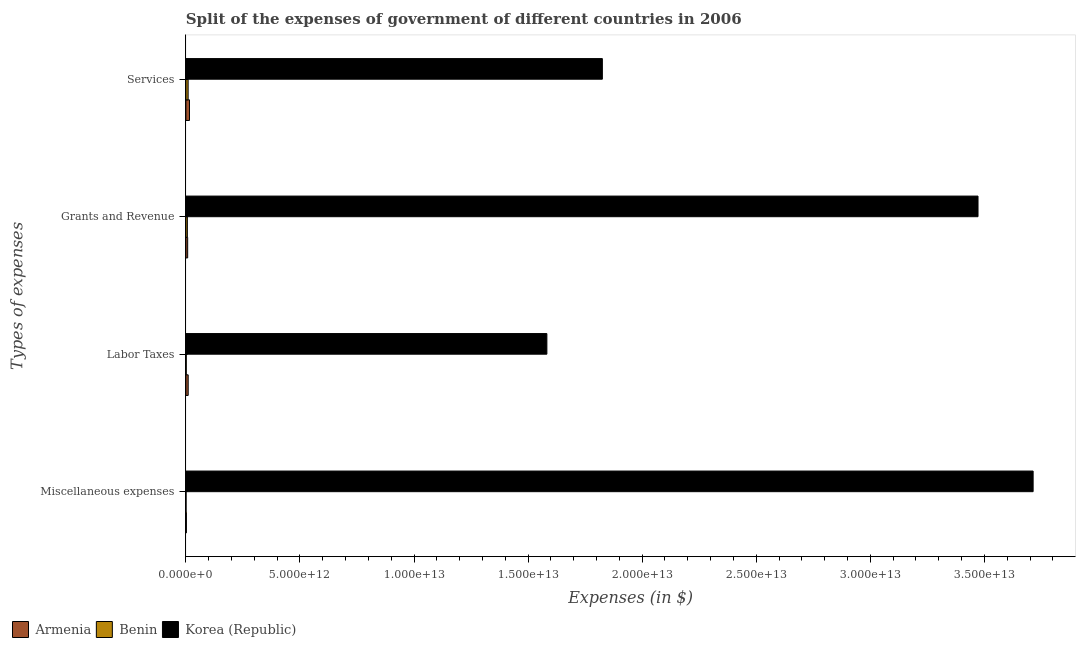How many bars are there on the 2nd tick from the bottom?
Give a very brief answer. 3. What is the label of the 2nd group of bars from the top?
Offer a terse response. Grants and Revenue. What is the amount spent on miscellaneous expenses in Armenia?
Give a very brief answer. 2.16e+1. Across all countries, what is the maximum amount spent on services?
Your answer should be very brief. 1.83e+13. Across all countries, what is the minimum amount spent on miscellaneous expenses?
Offer a terse response. 7.16e+09. In which country was the amount spent on labor taxes minimum?
Give a very brief answer. Benin. What is the total amount spent on services in the graph?
Keep it short and to the point. 1.85e+13. What is the difference between the amount spent on services in Benin and that in Armenia?
Keep it short and to the point. -5.98e+1. What is the difference between the amount spent on miscellaneous expenses in Armenia and the amount spent on labor taxes in Korea (Republic)?
Make the answer very short. -1.58e+13. What is the average amount spent on grants and revenue per country?
Ensure brevity in your answer.  1.16e+13. What is the difference between the amount spent on miscellaneous expenses and amount spent on grants and revenue in Korea (Republic)?
Make the answer very short. 2.42e+12. In how many countries, is the amount spent on grants and revenue greater than 18000000000000 $?
Give a very brief answer. 1. What is the ratio of the amount spent on grants and revenue in Armenia to that in Benin?
Provide a short and direct response. 1.21. Is the amount spent on grants and revenue in Armenia less than that in Korea (Republic)?
Provide a succinct answer. Yes. Is the difference between the amount spent on grants and revenue in Korea (Republic) and Armenia greater than the difference between the amount spent on miscellaneous expenses in Korea (Republic) and Armenia?
Your answer should be very brief. No. What is the difference between the highest and the second highest amount spent on labor taxes?
Your answer should be compact. 1.57e+13. What is the difference between the highest and the lowest amount spent on miscellaneous expenses?
Provide a short and direct response. 3.71e+13. In how many countries, is the amount spent on miscellaneous expenses greater than the average amount spent on miscellaneous expenses taken over all countries?
Keep it short and to the point. 1. Is the sum of the amount spent on miscellaneous expenses in Benin and Korea (Republic) greater than the maximum amount spent on labor taxes across all countries?
Your response must be concise. Yes. Is it the case that in every country, the sum of the amount spent on miscellaneous expenses and amount spent on services is greater than the sum of amount spent on grants and revenue and amount spent on labor taxes?
Offer a terse response. No. What does the 3rd bar from the top in Services represents?
Your answer should be compact. Armenia. What does the 3rd bar from the bottom in Grants and Revenue represents?
Your response must be concise. Korea (Republic). Are all the bars in the graph horizontal?
Provide a short and direct response. Yes. How many countries are there in the graph?
Offer a very short reply. 3. What is the difference between two consecutive major ticks on the X-axis?
Your response must be concise. 5.00e+12. Are the values on the major ticks of X-axis written in scientific E-notation?
Provide a succinct answer. Yes. Does the graph contain any zero values?
Provide a short and direct response. No. How many legend labels are there?
Ensure brevity in your answer.  3. What is the title of the graph?
Offer a terse response. Split of the expenses of government of different countries in 2006. What is the label or title of the X-axis?
Offer a very short reply. Expenses (in $). What is the label or title of the Y-axis?
Your answer should be very brief. Types of expenses. What is the Expenses (in $) of Armenia in Miscellaneous expenses?
Your answer should be very brief. 2.16e+1. What is the Expenses (in $) in Benin in Miscellaneous expenses?
Ensure brevity in your answer.  7.16e+09. What is the Expenses (in $) of Korea (Republic) in Miscellaneous expenses?
Your response must be concise. 3.71e+13. What is the Expenses (in $) of Armenia in Labor Taxes?
Make the answer very short. 1.01e+11. What is the Expenses (in $) of Benin in Labor Taxes?
Offer a very short reply. 1.62e+1. What is the Expenses (in $) in Korea (Republic) in Labor Taxes?
Ensure brevity in your answer.  1.58e+13. What is the Expenses (in $) of Armenia in Grants and Revenue?
Ensure brevity in your answer.  7.84e+1. What is the Expenses (in $) in Benin in Grants and Revenue?
Offer a terse response. 6.50e+1. What is the Expenses (in $) in Korea (Republic) in Grants and Revenue?
Give a very brief answer. 3.47e+13. What is the Expenses (in $) of Armenia in Services?
Make the answer very short. 1.58e+11. What is the Expenses (in $) in Benin in Services?
Keep it short and to the point. 9.86e+1. What is the Expenses (in $) of Korea (Republic) in Services?
Give a very brief answer. 1.83e+13. Across all Types of expenses, what is the maximum Expenses (in $) in Armenia?
Offer a very short reply. 1.58e+11. Across all Types of expenses, what is the maximum Expenses (in $) in Benin?
Your response must be concise. 9.86e+1. Across all Types of expenses, what is the maximum Expenses (in $) in Korea (Republic)?
Keep it short and to the point. 3.71e+13. Across all Types of expenses, what is the minimum Expenses (in $) in Armenia?
Offer a terse response. 2.16e+1. Across all Types of expenses, what is the minimum Expenses (in $) of Benin?
Ensure brevity in your answer.  7.16e+09. Across all Types of expenses, what is the minimum Expenses (in $) of Korea (Republic)?
Provide a short and direct response. 1.58e+13. What is the total Expenses (in $) in Armenia in the graph?
Offer a very short reply. 3.60e+11. What is the total Expenses (in $) of Benin in the graph?
Your response must be concise. 1.87e+11. What is the total Expenses (in $) of Korea (Republic) in the graph?
Your answer should be very brief. 1.06e+14. What is the difference between the Expenses (in $) in Armenia in Miscellaneous expenses and that in Labor Taxes?
Give a very brief answer. -7.96e+1. What is the difference between the Expenses (in $) of Benin in Miscellaneous expenses and that in Labor Taxes?
Your answer should be compact. -9.02e+09. What is the difference between the Expenses (in $) of Korea (Republic) in Miscellaneous expenses and that in Labor Taxes?
Give a very brief answer. 2.13e+13. What is the difference between the Expenses (in $) in Armenia in Miscellaneous expenses and that in Grants and Revenue?
Ensure brevity in your answer.  -5.68e+1. What is the difference between the Expenses (in $) in Benin in Miscellaneous expenses and that in Grants and Revenue?
Your answer should be compact. -5.78e+1. What is the difference between the Expenses (in $) in Korea (Republic) in Miscellaneous expenses and that in Grants and Revenue?
Offer a very short reply. 2.42e+12. What is the difference between the Expenses (in $) in Armenia in Miscellaneous expenses and that in Services?
Your answer should be very brief. -1.37e+11. What is the difference between the Expenses (in $) in Benin in Miscellaneous expenses and that in Services?
Provide a short and direct response. -9.15e+1. What is the difference between the Expenses (in $) of Korea (Republic) in Miscellaneous expenses and that in Services?
Ensure brevity in your answer.  1.89e+13. What is the difference between the Expenses (in $) of Armenia in Labor Taxes and that in Grants and Revenue?
Make the answer very short. 2.28e+1. What is the difference between the Expenses (in $) of Benin in Labor Taxes and that in Grants and Revenue?
Ensure brevity in your answer.  -4.88e+1. What is the difference between the Expenses (in $) in Korea (Republic) in Labor Taxes and that in Grants and Revenue?
Offer a very short reply. -1.89e+13. What is the difference between the Expenses (in $) of Armenia in Labor Taxes and that in Services?
Offer a very short reply. -5.71e+1. What is the difference between the Expenses (in $) in Benin in Labor Taxes and that in Services?
Provide a succinct answer. -8.24e+1. What is the difference between the Expenses (in $) of Korea (Republic) in Labor Taxes and that in Services?
Your answer should be very brief. -2.43e+12. What is the difference between the Expenses (in $) in Armenia in Grants and Revenue and that in Services?
Provide a succinct answer. -8.00e+1. What is the difference between the Expenses (in $) in Benin in Grants and Revenue and that in Services?
Give a very brief answer. -3.36e+1. What is the difference between the Expenses (in $) in Korea (Republic) in Grants and Revenue and that in Services?
Make the answer very short. 1.65e+13. What is the difference between the Expenses (in $) in Armenia in Miscellaneous expenses and the Expenses (in $) in Benin in Labor Taxes?
Keep it short and to the point. 5.43e+09. What is the difference between the Expenses (in $) of Armenia in Miscellaneous expenses and the Expenses (in $) of Korea (Republic) in Labor Taxes?
Ensure brevity in your answer.  -1.58e+13. What is the difference between the Expenses (in $) in Benin in Miscellaneous expenses and the Expenses (in $) in Korea (Republic) in Labor Taxes?
Offer a terse response. -1.58e+13. What is the difference between the Expenses (in $) in Armenia in Miscellaneous expenses and the Expenses (in $) in Benin in Grants and Revenue?
Keep it short and to the point. -4.34e+1. What is the difference between the Expenses (in $) in Armenia in Miscellaneous expenses and the Expenses (in $) in Korea (Republic) in Grants and Revenue?
Offer a terse response. -3.47e+13. What is the difference between the Expenses (in $) in Benin in Miscellaneous expenses and the Expenses (in $) in Korea (Republic) in Grants and Revenue?
Give a very brief answer. -3.47e+13. What is the difference between the Expenses (in $) of Armenia in Miscellaneous expenses and the Expenses (in $) of Benin in Services?
Your answer should be compact. -7.70e+1. What is the difference between the Expenses (in $) of Armenia in Miscellaneous expenses and the Expenses (in $) of Korea (Republic) in Services?
Offer a terse response. -1.82e+13. What is the difference between the Expenses (in $) in Benin in Miscellaneous expenses and the Expenses (in $) in Korea (Republic) in Services?
Your response must be concise. -1.82e+13. What is the difference between the Expenses (in $) of Armenia in Labor Taxes and the Expenses (in $) of Benin in Grants and Revenue?
Keep it short and to the point. 3.63e+1. What is the difference between the Expenses (in $) in Armenia in Labor Taxes and the Expenses (in $) in Korea (Republic) in Grants and Revenue?
Offer a terse response. -3.46e+13. What is the difference between the Expenses (in $) in Benin in Labor Taxes and the Expenses (in $) in Korea (Republic) in Grants and Revenue?
Offer a very short reply. -3.47e+13. What is the difference between the Expenses (in $) in Armenia in Labor Taxes and the Expenses (in $) in Benin in Services?
Your answer should be very brief. 2.64e+09. What is the difference between the Expenses (in $) in Armenia in Labor Taxes and the Expenses (in $) in Korea (Republic) in Services?
Provide a short and direct response. -1.82e+13. What is the difference between the Expenses (in $) of Benin in Labor Taxes and the Expenses (in $) of Korea (Republic) in Services?
Your answer should be very brief. -1.82e+13. What is the difference between the Expenses (in $) in Armenia in Grants and Revenue and the Expenses (in $) in Benin in Services?
Keep it short and to the point. -2.02e+1. What is the difference between the Expenses (in $) in Armenia in Grants and Revenue and the Expenses (in $) in Korea (Republic) in Services?
Your response must be concise. -1.82e+13. What is the difference between the Expenses (in $) of Benin in Grants and Revenue and the Expenses (in $) of Korea (Republic) in Services?
Ensure brevity in your answer.  -1.82e+13. What is the average Expenses (in $) of Armenia per Types of expenses?
Provide a succinct answer. 8.99e+1. What is the average Expenses (in $) in Benin per Types of expenses?
Keep it short and to the point. 4.67e+1. What is the average Expenses (in $) in Korea (Republic) per Types of expenses?
Make the answer very short. 2.65e+13. What is the difference between the Expenses (in $) in Armenia and Expenses (in $) in Benin in Miscellaneous expenses?
Provide a succinct answer. 1.45e+1. What is the difference between the Expenses (in $) of Armenia and Expenses (in $) of Korea (Republic) in Miscellaneous expenses?
Provide a succinct answer. -3.71e+13. What is the difference between the Expenses (in $) of Benin and Expenses (in $) of Korea (Republic) in Miscellaneous expenses?
Keep it short and to the point. -3.71e+13. What is the difference between the Expenses (in $) in Armenia and Expenses (in $) in Benin in Labor Taxes?
Provide a short and direct response. 8.51e+1. What is the difference between the Expenses (in $) of Armenia and Expenses (in $) of Korea (Republic) in Labor Taxes?
Keep it short and to the point. -1.57e+13. What is the difference between the Expenses (in $) of Benin and Expenses (in $) of Korea (Republic) in Labor Taxes?
Ensure brevity in your answer.  -1.58e+13. What is the difference between the Expenses (in $) in Armenia and Expenses (in $) in Benin in Grants and Revenue?
Your answer should be very brief. 1.35e+1. What is the difference between the Expenses (in $) in Armenia and Expenses (in $) in Korea (Republic) in Grants and Revenue?
Provide a short and direct response. -3.46e+13. What is the difference between the Expenses (in $) of Benin and Expenses (in $) of Korea (Republic) in Grants and Revenue?
Make the answer very short. -3.47e+13. What is the difference between the Expenses (in $) of Armenia and Expenses (in $) of Benin in Services?
Give a very brief answer. 5.98e+1. What is the difference between the Expenses (in $) in Armenia and Expenses (in $) in Korea (Republic) in Services?
Provide a succinct answer. -1.81e+13. What is the difference between the Expenses (in $) in Benin and Expenses (in $) in Korea (Republic) in Services?
Provide a short and direct response. -1.82e+13. What is the ratio of the Expenses (in $) of Armenia in Miscellaneous expenses to that in Labor Taxes?
Keep it short and to the point. 0.21. What is the ratio of the Expenses (in $) of Benin in Miscellaneous expenses to that in Labor Taxes?
Keep it short and to the point. 0.44. What is the ratio of the Expenses (in $) in Korea (Republic) in Miscellaneous expenses to that in Labor Taxes?
Keep it short and to the point. 2.35. What is the ratio of the Expenses (in $) of Armenia in Miscellaneous expenses to that in Grants and Revenue?
Your answer should be compact. 0.28. What is the ratio of the Expenses (in $) in Benin in Miscellaneous expenses to that in Grants and Revenue?
Ensure brevity in your answer.  0.11. What is the ratio of the Expenses (in $) in Korea (Republic) in Miscellaneous expenses to that in Grants and Revenue?
Offer a very short reply. 1.07. What is the ratio of the Expenses (in $) of Armenia in Miscellaneous expenses to that in Services?
Make the answer very short. 0.14. What is the ratio of the Expenses (in $) in Benin in Miscellaneous expenses to that in Services?
Give a very brief answer. 0.07. What is the ratio of the Expenses (in $) in Korea (Republic) in Miscellaneous expenses to that in Services?
Keep it short and to the point. 2.03. What is the ratio of the Expenses (in $) in Armenia in Labor Taxes to that in Grants and Revenue?
Your answer should be compact. 1.29. What is the ratio of the Expenses (in $) in Benin in Labor Taxes to that in Grants and Revenue?
Your answer should be compact. 0.25. What is the ratio of the Expenses (in $) of Korea (Republic) in Labor Taxes to that in Grants and Revenue?
Keep it short and to the point. 0.46. What is the ratio of the Expenses (in $) of Armenia in Labor Taxes to that in Services?
Offer a very short reply. 0.64. What is the ratio of the Expenses (in $) in Benin in Labor Taxes to that in Services?
Offer a very short reply. 0.16. What is the ratio of the Expenses (in $) in Korea (Republic) in Labor Taxes to that in Services?
Your answer should be very brief. 0.87. What is the ratio of the Expenses (in $) in Armenia in Grants and Revenue to that in Services?
Give a very brief answer. 0.5. What is the ratio of the Expenses (in $) of Benin in Grants and Revenue to that in Services?
Keep it short and to the point. 0.66. What is the ratio of the Expenses (in $) of Korea (Republic) in Grants and Revenue to that in Services?
Ensure brevity in your answer.  1.9. What is the difference between the highest and the second highest Expenses (in $) of Armenia?
Give a very brief answer. 5.71e+1. What is the difference between the highest and the second highest Expenses (in $) in Benin?
Provide a short and direct response. 3.36e+1. What is the difference between the highest and the second highest Expenses (in $) of Korea (Republic)?
Your answer should be very brief. 2.42e+12. What is the difference between the highest and the lowest Expenses (in $) of Armenia?
Your answer should be very brief. 1.37e+11. What is the difference between the highest and the lowest Expenses (in $) of Benin?
Provide a succinct answer. 9.15e+1. What is the difference between the highest and the lowest Expenses (in $) of Korea (Republic)?
Give a very brief answer. 2.13e+13. 